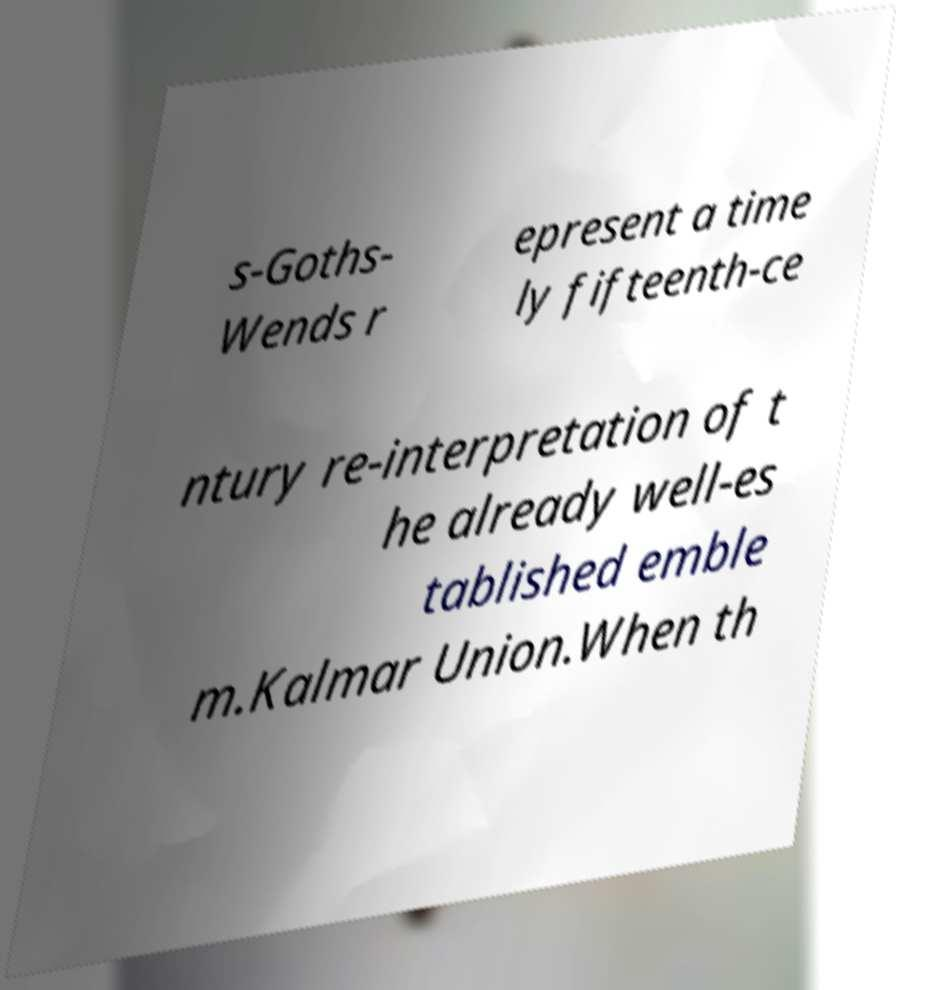Please identify and transcribe the text found in this image. s-Goths- Wends r epresent a time ly fifteenth-ce ntury re-interpretation of t he already well-es tablished emble m.Kalmar Union.When th 